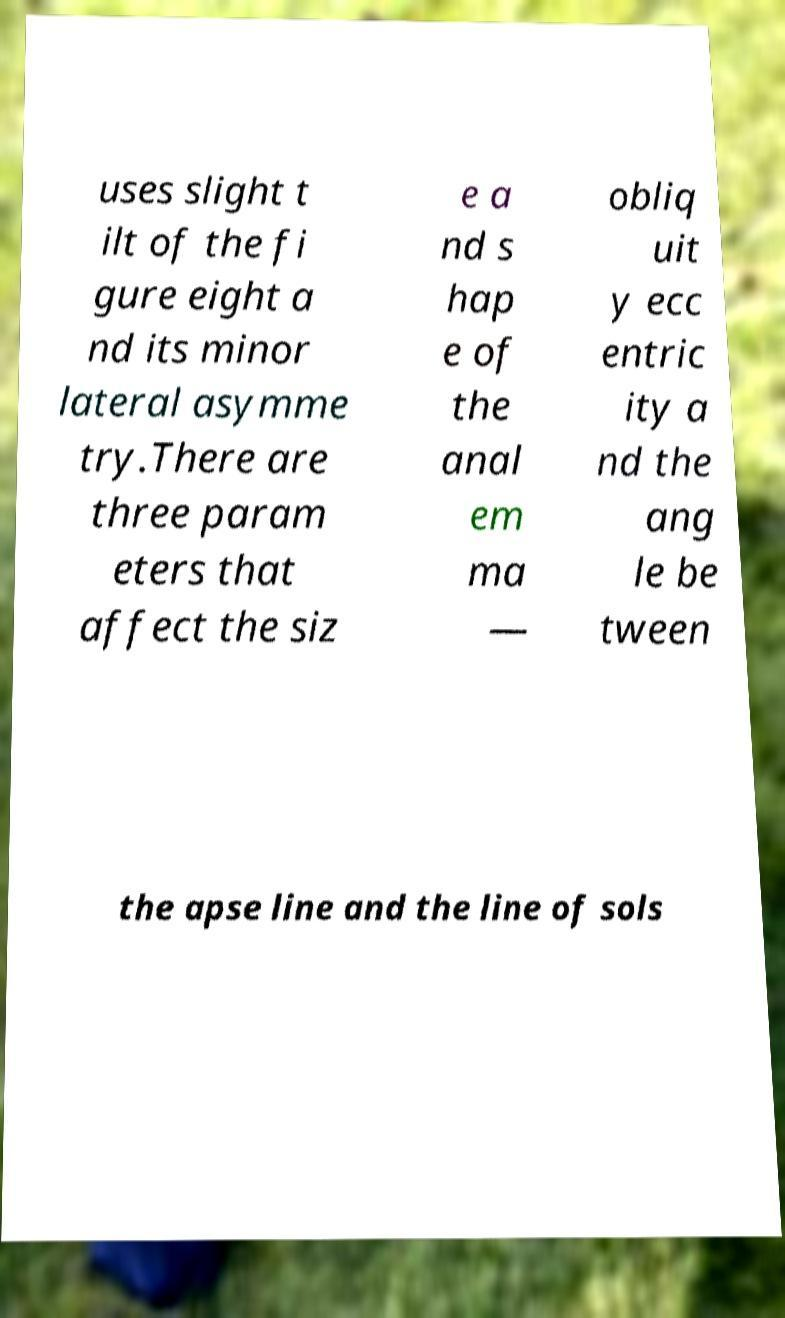Can you accurately transcribe the text from the provided image for me? uses slight t ilt of the fi gure eight a nd its minor lateral asymme try.There are three param eters that affect the siz e a nd s hap e of the anal em ma — obliq uit y ecc entric ity a nd the ang le be tween the apse line and the line of sols 